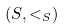Convert formula to latex. <formula><loc_0><loc_0><loc_500><loc_500>( S , < _ { S } )</formula> 